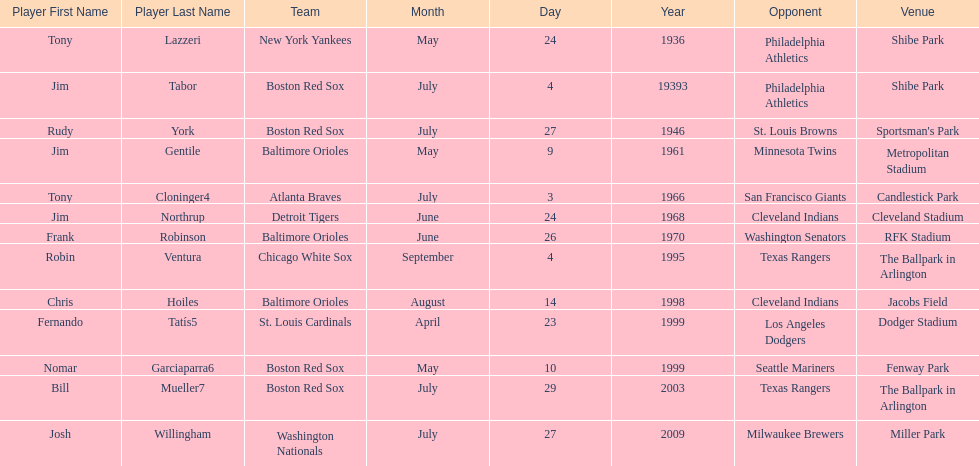Which teams faced off at miller park? Washington Nationals, Milwaukee Brewers. Could you help me parse every detail presented in this table? {'header': ['Player First Name', 'Player Last Name', 'Team', 'Month', 'Day', 'Year', 'Opponent', 'Venue'], 'rows': [['Tony', 'Lazzeri', 'New York Yankees', 'May', '24', '1936', 'Philadelphia Athletics', 'Shibe Park'], ['Jim', 'Tabor', 'Boston Red Sox', 'July', '4', '19393', 'Philadelphia Athletics', 'Shibe Park'], ['Rudy', 'York', 'Boston Red Sox', 'July', '27', '1946', 'St. Louis Browns', "Sportsman's Park"], ['Jim', 'Gentile', 'Baltimore Orioles', 'May', '9', '1961', 'Minnesota Twins', 'Metropolitan Stadium'], ['Tony', 'Cloninger4', 'Atlanta Braves', 'July', '3', '1966', 'San Francisco Giants', 'Candlestick Park'], ['Jim', 'Northrup', 'Detroit Tigers', 'June', '24', '1968', 'Cleveland Indians', 'Cleveland Stadium'], ['Frank', 'Robinson', 'Baltimore Orioles', 'June', '26', '1970', 'Washington Senators', 'RFK Stadium'], ['Robin', 'Ventura', 'Chicago White Sox', 'September', '4', '1995', 'Texas Rangers', 'The Ballpark in Arlington'], ['Chris', 'Hoiles', 'Baltimore Orioles', 'August', '14', '1998', 'Cleveland Indians', 'Jacobs Field'], ['Fernando', 'Tatís5', 'St. Louis Cardinals', 'April', '23', '1999', 'Los Angeles Dodgers', 'Dodger Stadium'], ['Nomar', 'Garciaparra6', 'Boston Red Sox', 'May', '10', '1999', 'Seattle Mariners', 'Fenway Park'], ['Bill', 'Mueller7', 'Boston Red Sox', 'July', '29', '2003', 'Texas Rangers', 'The Ballpark in Arlington'], ['Josh', 'Willingham', 'Washington Nationals', 'July', '27', '2009', 'Milwaukee Brewers', 'Miller Park']]} 